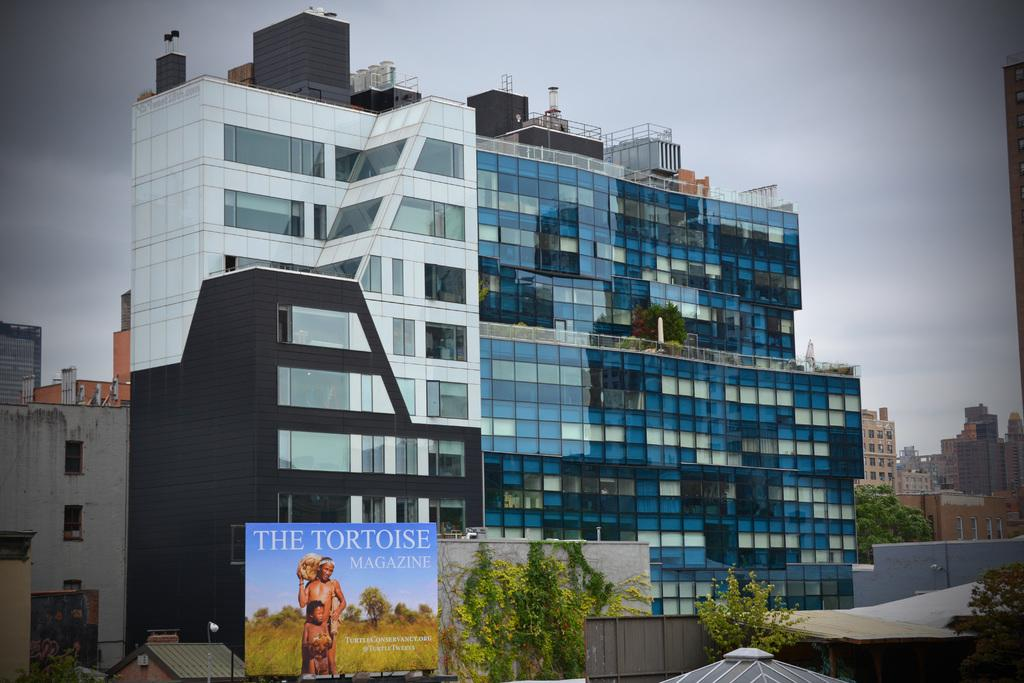What type of structures can be seen in the image? There are buildings in the image. What other natural elements are present in the image? There are trees in the image. What is attached to one of the buildings in the image? There is a poster on one of the buildings in the image. What can be read on the poster? There is text on the poster, and there are pictures of two people on the poster. What is visible in the background of the image? The sky is visible in the image. What type of transport is being used by the people in the image? There are no people visible in the image, only a poster with pictures of two people. How does the poster affect the health of the people in the image? The poster does not have any direct impact on the health of the people in the image, as it is a static image with pictures of two people. 